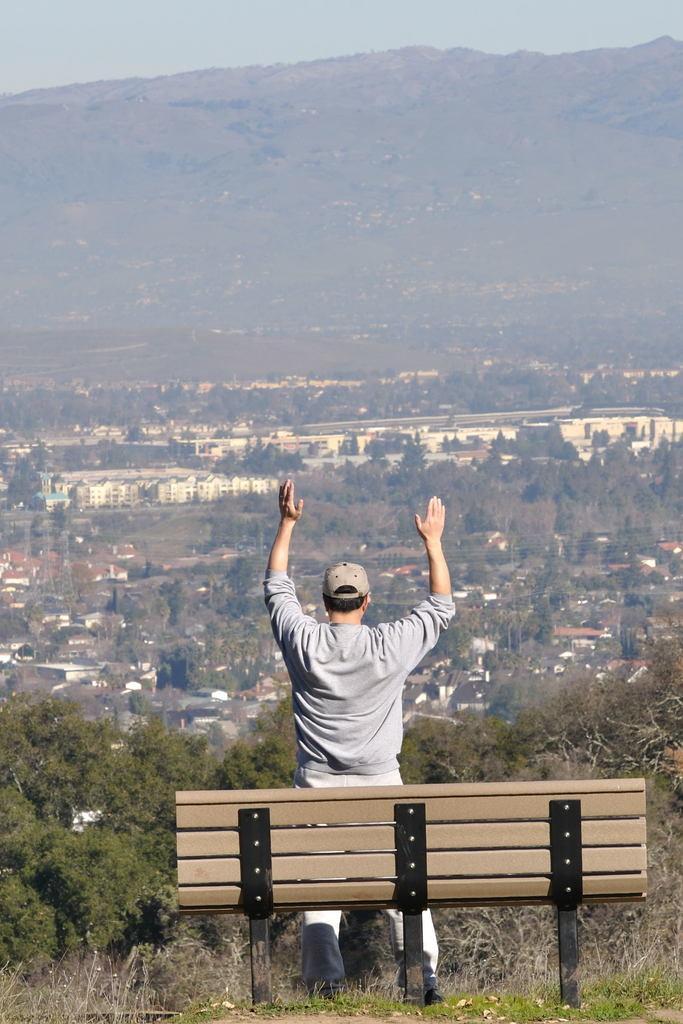How would you summarize this image in a sentence or two? There is a person standing in front of a bench. In the background we can see sky,mountain,trees and buildings. 